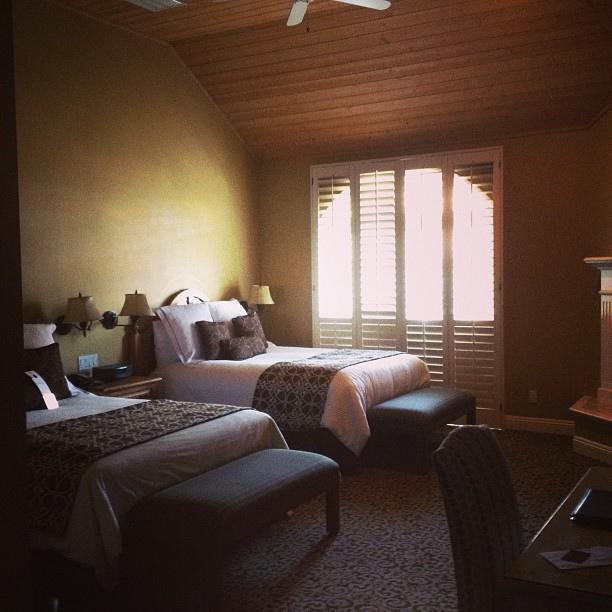How many beds are in the picture?
Give a very brief answer. 2. How many lamps are in the room?
Give a very brief answer. 3. How many windows are there?
Give a very brief answer. 1. How many lamps are in the picture?
Give a very brief answer. 3. How many people would be able to sleep in this bed?
Give a very brief answer. 2. How many beds are in the photo?
Give a very brief answer. 2. 